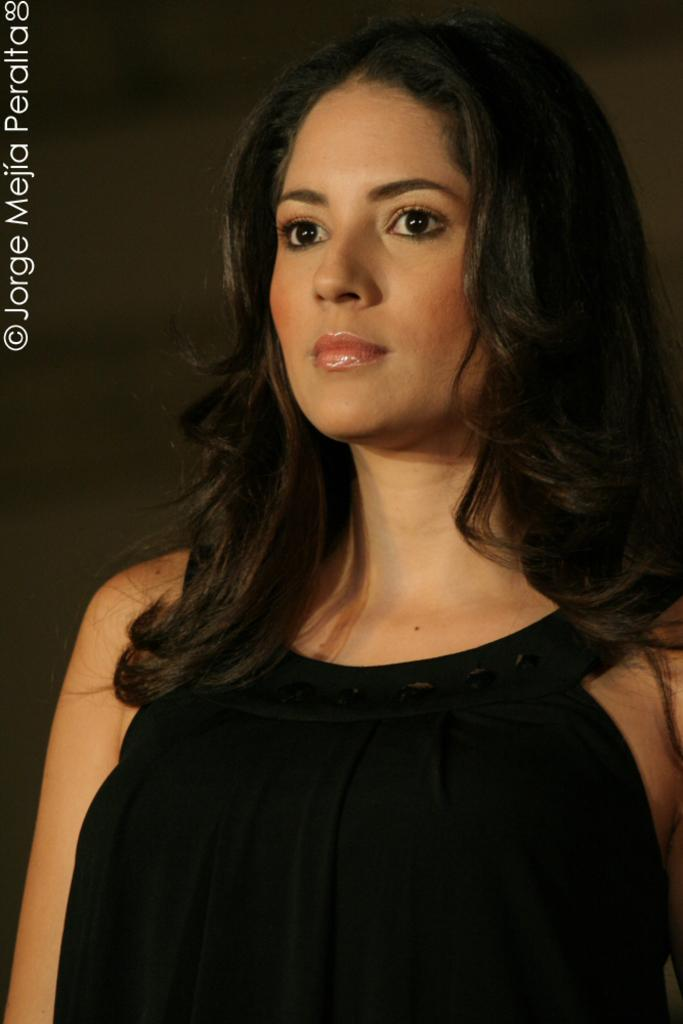Who is present in the image? There are women in the image. What are the women wearing? The women are wearing black dresses. What type of fruit is being peeled by the women in the image? There is no fruit present in the image, let alone being peeled by the women. 